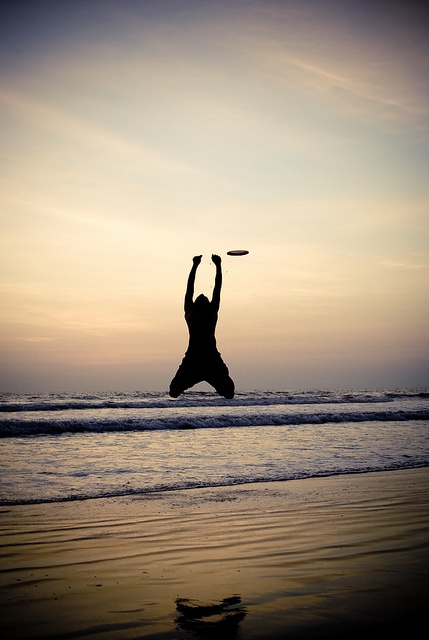Describe the objects in this image and their specific colors. I can see people in black, beige, darkgray, and tan tones and frisbee in black, gray, and purple tones in this image. 